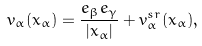<formula> <loc_0><loc_0><loc_500><loc_500>v _ { \alpha } ( x _ { \alpha } ) = \frac { e _ { \beta } e _ { \gamma } } { | x _ { \alpha } | } + v ^ { s r } _ { \alpha } ( x _ { \alpha } ) ,</formula> 